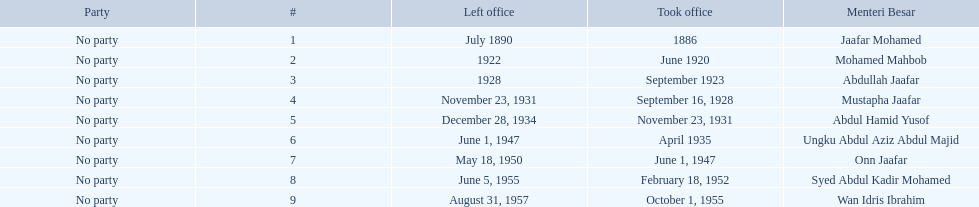Who were all of the menteri besars? Jaafar Mohamed, Mohamed Mahbob, Abdullah Jaafar, Mustapha Jaafar, Abdul Hamid Yusof, Ungku Abdul Aziz Abdul Majid, Onn Jaafar, Syed Abdul Kadir Mohamed, Wan Idris Ibrahim. When did they take office? 1886, June 1920, September 1923, September 16, 1928, November 23, 1931, April 1935, June 1, 1947, February 18, 1952, October 1, 1955. And when did they leave? July 1890, 1922, 1928, November 23, 1931, December 28, 1934, June 1, 1947, May 18, 1950, June 5, 1955, August 31, 1957. Now, who was in office for less than four years? Mohamed Mahbob. 